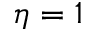<formula> <loc_0><loc_0><loc_500><loc_500>\eta = 1</formula> 